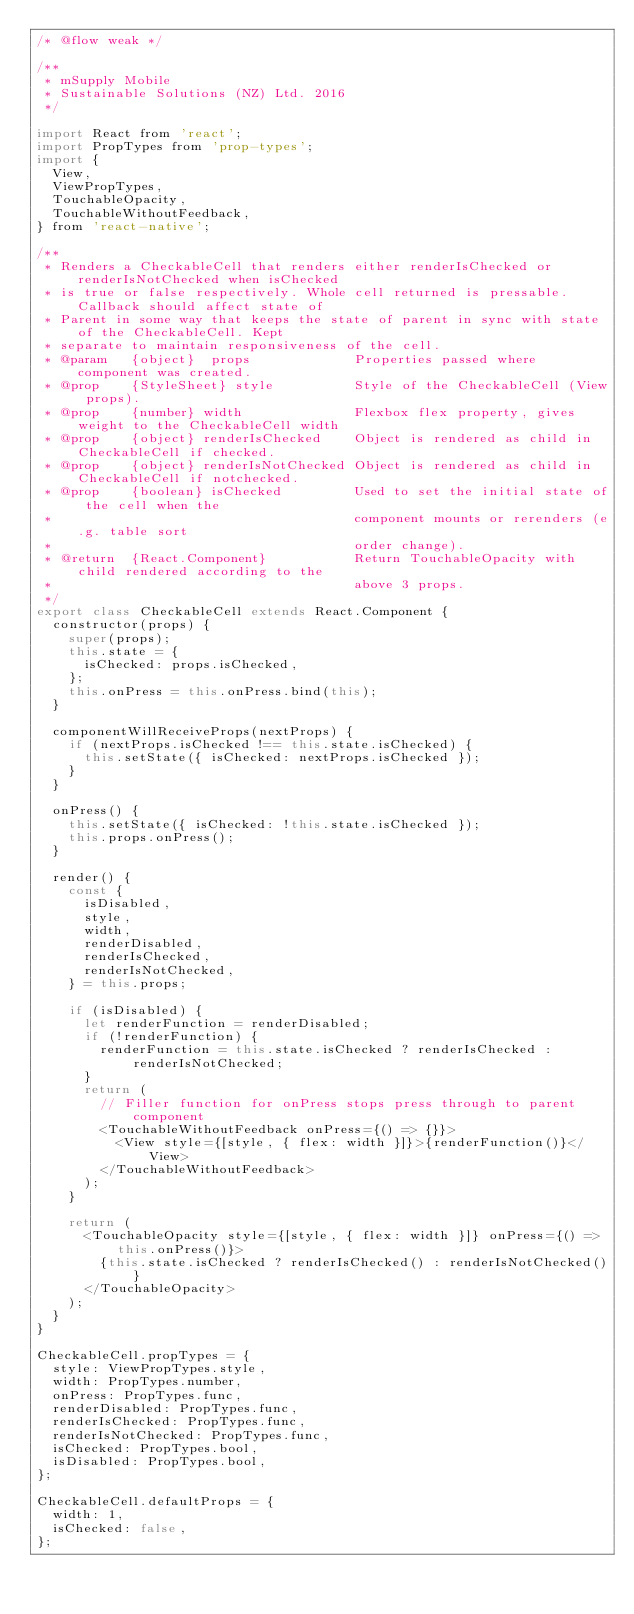Convert code to text. <code><loc_0><loc_0><loc_500><loc_500><_JavaScript_>/* @flow weak */

/**
 * mSupply Mobile
 * Sustainable Solutions (NZ) Ltd. 2016
 */

import React from 'react';
import PropTypes from 'prop-types';
import {
  View,
  ViewPropTypes,
  TouchableOpacity,
  TouchableWithoutFeedback,
} from 'react-native';

/**
 * Renders a CheckableCell that renders either renderIsChecked or renderIsNotChecked when isChecked
 * is true or false respectively. Whole cell returned is pressable. Callback should affect state of
 * Parent in some way that keeps the state of parent in sync with state of the CheckableCell. Kept
 * separate to maintain responsiveness of the cell.
 * @param   {object}  props             Properties passed where component was created.
 * @prop    {StyleSheet} style          Style of the CheckableCell (View props).
 * @prop    {number} width              Flexbox flex property, gives weight to the CheckableCell width
 * @prop    {object} renderIsChecked    Object is rendered as child in CheckableCell if checked.
 * @prop    {object} renderIsNotChecked Object is rendered as child in CheckableCell if notchecked.
 * @prop    {boolean} isChecked         Used to set the initial state of the cell when the
 *                                      component mounts or rerenders (e.g. table sort
 *                                      order change).
 * @return  {React.Component}           Return TouchableOpacity with child rendered according to the
 *                                      above 3 props.
 */
export class CheckableCell extends React.Component {
  constructor(props) {
    super(props);
    this.state = {
      isChecked: props.isChecked,
    };
    this.onPress = this.onPress.bind(this);
  }

  componentWillReceiveProps(nextProps) {
    if (nextProps.isChecked !== this.state.isChecked) {
      this.setState({ isChecked: nextProps.isChecked });
    }
  }

  onPress() {
    this.setState({ isChecked: !this.state.isChecked });
    this.props.onPress();
  }

  render() {
    const {
      isDisabled,
      style,
      width,
      renderDisabled,
      renderIsChecked,
      renderIsNotChecked,
    } = this.props;

    if (isDisabled) {
      let renderFunction = renderDisabled;
      if (!renderFunction) {
        renderFunction = this.state.isChecked ? renderIsChecked : renderIsNotChecked;
      }
      return (
        // Filler function for onPress stops press through to parent component
        <TouchableWithoutFeedback onPress={() => {}}>
          <View style={[style, { flex: width }]}>{renderFunction()}</View>
        </TouchableWithoutFeedback>
      );
    }

    return (
      <TouchableOpacity style={[style, { flex: width }]} onPress={() => this.onPress()}>
        {this.state.isChecked ? renderIsChecked() : renderIsNotChecked()}
      </TouchableOpacity>
    );
  }
}

CheckableCell.propTypes = {
  style: ViewPropTypes.style,
  width: PropTypes.number,
  onPress: PropTypes.func,
  renderDisabled: PropTypes.func,
  renderIsChecked: PropTypes.func,
  renderIsNotChecked: PropTypes.func,
  isChecked: PropTypes.bool,
  isDisabled: PropTypes.bool,
};

CheckableCell.defaultProps = {
  width: 1,
  isChecked: false,
};
</code> 